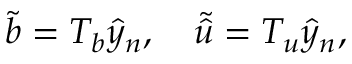Convert formula to latex. <formula><loc_0><loc_0><loc_500><loc_500>\tilde { b } = T _ { b } \hat { y } _ { n } , \quad \tilde { \hat { u } } = T _ { u } \hat { y } _ { n } ,</formula> 